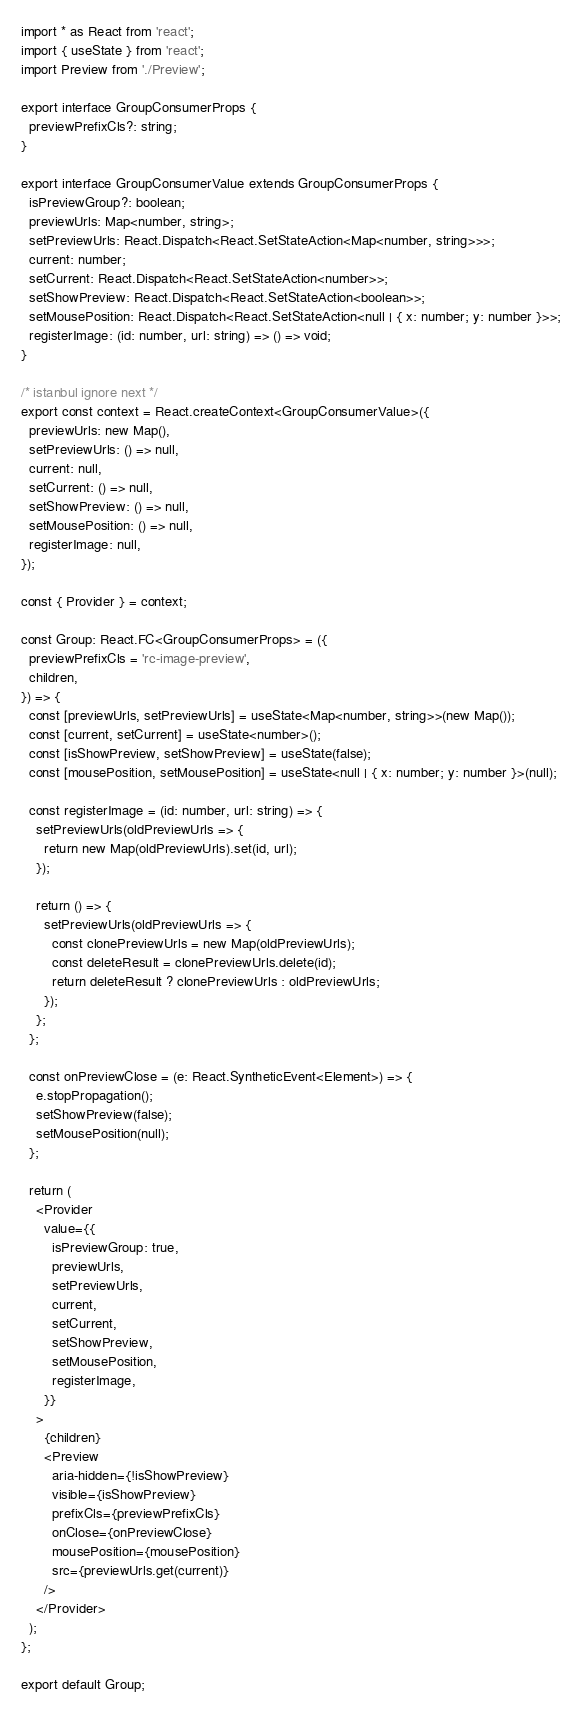<code> <loc_0><loc_0><loc_500><loc_500><_TypeScript_>import * as React from 'react';
import { useState } from 'react';
import Preview from './Preview';

export interface GroupConsumerProps {
  previewPrefixCls?: string;
}

export interface GroupConsumerValue extends GroupConsumerProps {
  isPreviewGroup?: boolean;
  previewUrls: Map<number, string>;
  setPreviewUrls: React.Dispatch<React.SetStateAction<Map<number, string>>>;
  current: number;
  setCurrent: React.Dispatch<React.SetStateAction<number>>;
  setShowPreview: React.Dispatch<React.SetStateAction<boolean>>;
  setMousePosition: React.Dispatch<React.SetStateAction<null | { x: number; y: number }>>;
  registerImage: (id: number, url: string) => () => void;
}

/* istanbul ignore next */
export const context = React.createContext<GroupConsumerValue>({
  previewUrls: new Map(),
  setPreviewUrls: () => null,
  current: null,
  setCurrent: () => null,
  setShowPreview: () => null,
  setMousePosition: () => null,
  registerImage: null,
});

const { Provider } = context;

const Group: React.FC<GroupConsumerProps> = ({
  previewPrefixCls = 'rc-image-preview',
  children,
}) => {
  const [previewUrls, setPreviewUrls] = useState<Map<number, string>>(new Map());
  const [current, setCurrent] = useState<number>();
  const [isShowPreview, setShowPreview] = useState(false);
  const [mousePosition, setMousePosition] = useState<null | { x: number; y: number }>(null);

  const registerImage = (id: number, url: string) => {
    setPreviewUrls(oldPreviewUrls => {
      return new Map(oldPreviewUrls).set(id, url);
    });

    return () => {
      setPreviewUrls(oldPreviewUrls => {
        const clonePreviewUrls = new Map(oldPreviewUrls);
        const deleteResult = clonePreviewUrls.delete(id);
        return deleteResult ? clonePreviewUrls : oldPreviewUrls;
      });
    };
  };

  const onPreviewClose = (e: React.SyntheticEvent<Element>) => {
    e.stopPropagation();
    setShowPreview(false);
    setMousePosition(null);
  };

  return (
    <Provider
      value={{
        isPreviewGroup: true,
        previewUrls,
        setPreviewUrls,
        current,
        setCurrent,
        setShowPreview,
        setMousePosition,
        registerImage,
      }}
    >
      {children}
      <Preview
        aria-hidden={!isShowPreview}
        visible={isShowPreview}
        prefixCls={previewPrefixCls}
        onClose={onPreviewClose}
        mousePosition={mousePosition}
        src={previewUrls.get(current)}
      />
    </Provider>
  );
};

export default Group;
</code> 